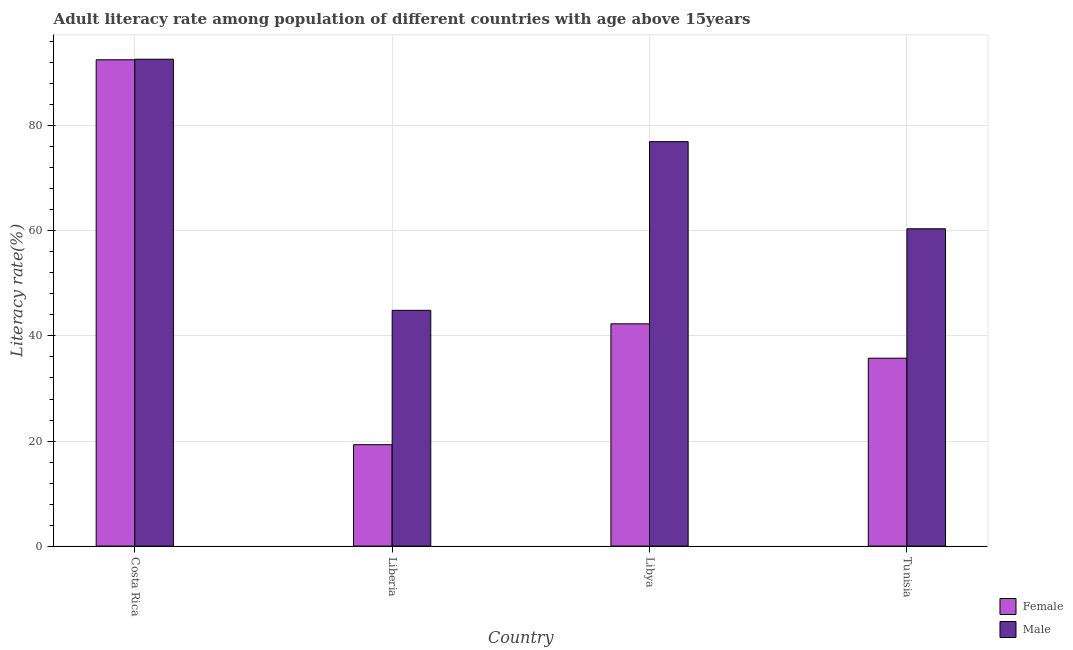Are the number of bars per tick equal to the number of legend labels?
Your answer should be compact. Yes. How many bars are there on the 2nd tick from the right?
Make the answer very short. 2. What is the male adult literacy rate in Libya?
Offer a very short reply. 76.99. Across all countries, what is the maximum male adult literacy rate?
Make the answer very short. 92.68. Across all countries, what is the minimum male adult literacy rate?
Offer a terse response. 44.88. In which country was the male adult literacy rate minimum?
Ensure brevity in your answer.  Liberia. What is the total male adult literacy rate in the graph?
Your answer should be very brief. 274.96. What is the difference between the female adult literacy rate in Liberia and that in Tunisia?
Your answer should be compact. -16.46. What is the difference between the male adult literacy rate in Liberia and the female adult literacy rate in Costa Rica?
Make the answer very short. -47.7. What is the average female adult literacy rate per country?
Provide a succinct answer. 47.49. What is the difference between the male adult literacy rate and female adult literacy rate in Tunisia?
Your answer should be very brief. 24.64. What is the ratio of the male adult literacy rate in Libya to that in Tunisia?
Provide a short and direct response. 1.27. What is the difference between the highest and the second highest female adult literacy rate?
Your answer should be very brief. 50.26. What is the difference between the highest and the lowest male adult literacy rate?
Offer a terse response. 47.8. In how many countries, is the female adult literacy rate greater than the average female adult literacy rate taken over all countries?
Provide a short and direct response. 1. Is the sum of the male adult literacy rate in Liberia and Libya greater than the maximum female adult literacy rate across all countries?
Provide a succinct answer. Yes. How many countries are there in the graph?
Make the answer very short. 4. Are the values on the major ticks of Y-axis written in scientific E-notation?
Your answer should be compact. No. Where does the legend appear in the graph?
Provide a short and direct response. Bottom right. What is the title of the graph?
Keep it short and to the point. Adult literacy rate among population of different countries with age above 15years. What is the label or title of the X-axis?
Your answer should be very brief. Country. What is the label or title of the Y-axis?
Ensure brevity in your answer.  Literacy rate(%). What is the Literacy rate(%) of Female in Costa Rica?
Your answer should be very brief. 92.58. What is the Literacy rate(%) of Male in Costa Rica?
Offer a terse response. 92.68. What is the Literacy rate(%) in Female in Liberia?
Keep it short and to the point. 19.3. What is the Literacy rate(%) of Male in Liberia?
Make the answer very short. 44.88. What is the Literacy rate(%) in Female in Libya?
Offer a terse response. 42.31. What is the Literacy rate(%) in Male in Libya?
Your answer should be compact. 76.99. What is the Literacy rate(%) of Female in Tunisia?
Your answer should be very brief. 35.77. What is the Literacy rate(%) of Male in Tunisia?
Give a very brief answer. 60.41. Across all countries, what is the maximum Literacy rate(%) of Female?
Your response must be concise. 92.58. Across all countries, what is the maximum Literacy rate(%) in Male?
Provide a short and direct response. 92.68. Across all countries, what is the minimum Literacy rate(%) in Female?
Make the answer very short. 19.3. Across all countries, what is the minimum Literacy rate(%) in Male?
Make the answer very short. 44.88. What is the total Literacy rate(%) in Female in the graph?
Provide a short and direct response. 189.96. What is the total Literacy rate(%) in Male in the graph?
Make the answer very short. 274.96. What is the difference between the Literacy rate(%) of Female in Costa Rica and that in Liberia?
Ensure brevity in your answer.  73.27. What is the difference between the Literacy rate(%) of Male in Costa Rica and that in Liberia?
Provide a succinct answer. 47.8. What is the difference between the Literacy rate(%) of Female in Costa Rica and that in Libya?
Your answer should be very brief. 50.26. What is the difference between the Literacy rate(%) in Male in Costa Rica and that in Libya?
Make the answer very short. 15.69. What is the difference between the Literacy rate(%) in Female in Costa Rica and that in Tunisia?
Your answer should be compact. 56.81. What is the difference between the Literacy rate(%) in Male in Costa Rica and that in Tunisia?
Ensure brevity in your answer.  32.27. What is the difference between the Literacy rate(%) in Female in Liberia and that in Libya?
Your answer should be compact. -23.01. What is the difference between the Literacy rate(%) in Male in Liberia and that in Libya?
Provide a succinct answer. -32.11. What is the difference between the Literacy rate(%) in Female in Liberia and that in Tunisia?
Offer a very short reply. -16.46. What is the difference between the Literacy rate(%) of Male in Liberia and that in Tunisia?
Your response must be concise. -15.53. What is the difference between the Literacy rate(%) in Female in Libya and that in Tunisia?
Your response must be concise. 6.55. What is the difference between the Literacy rate(%) in Male in Libya and that in Tunisia?
Provide a succinct answer. 16.59. What is the difference between the Literacy rate(%) of Female in Costa Rica and the Literacy rate(%) of Male in Liberia?
Your answer should be very brief. 47.7. What is the difference between the Literacy rate(%) in Female in Costa Rica and the Literacy rate(%) in Male in Libya?
Make the answer very short. 15.58. What is the difference between the Literacy rate(%) of Female in Costa Rica and the Literacy rate(%) of Male in Tunisia?
Your answer should be compact. 32.17. What is the difference between the Literacy rate(%) in Female in Liberia and the Literacy rate(%) in Male in Libya?
Provide a short and direct response. -57.69. What is the difference between the Literacy rate(%) of Female in Liberia and the Literacy rate(%) of Male in Tunisia?
Keep it short and to the point. -41.1. What is the difference between the Literacy rate(%) of Female in Libya and the Literacy rate(%) of Male in Tunisia?
Make the answer very short. -18.09. What is the average Literacy rate(%) of Female per country?
Offer a very short reply. 47.49. What is the average Literacy rate(%) of Male per country?
Offer a terse response. 68.74. What is the difference between the Literacy rate(%) of Female and Literacy rate(%) of Male in Costa Rica?
Ensure brevity in your answer.  -0.1. What is the difference between the Literacy rate(%) of Female and Literacy rate(%) of Male in Liberia?
Your response must be concise. -25.58. What is the difference between the Literacy rate(%) of Female and Literacy rate(%) of Male in Libya?
Provide a short and direct response. -34.68. What is the difference between the Literacy rate(%) of Female and Literacy rate(%) of Male in Tunisia?
Your response must be concise. -24.64. What is the ratio of the Literacy rate(%) in Female in Costa Rica to that in Liberia?
Provide a succinct answer. 4.8. What is the ratio of the Literacy rate(%) of Male in Costa Rica to that in Liberia?
Make the answer very short. 2.07. What is the ratio of the Literacy rate(%) in Female in Costa Rica to that in Libya?
Keep it short and to the point. 2.19. What is the ratio of the Literacy rate(%) of Male in Costa Rica to that in Libya?
Provide a short and direct response. 1.2. What is the ratio of the Literacy rate(%) in Female in Costa Rica to that in Tunisia?
Give a very brief answer. 2.59. What is the ratio of the Literacy rate(%) in Male in Costa Rica to that in Tunisia?
Ensure brevity in your answer.  1.53. What is the ratio of the Literacy rate(%) in Female in Liberia to that in Libya?
Your answer should be very brief. 0.46. What is the ratio of the Literacy rate(%) of Male in Liberia to that in Libya?
Your response must be concise. 0.58. What is the ratio of the Literacy rate(%) in Female in Liberia to that in Tunisia?
Offer a terse response. 0.54. What is the ratio of the Literacy rate(%) of Male in Liberia to that in Tunisia?
Your answer should be very brief. 0.74. What is the ratio of the Literacy rate(%) of Female in Libya to that in Tunisia?
Give a very brief answer. 1.18. What is the ratio of the Literacy rate(%) of Male in Libya to that in Tunisia?
Provide a short and direct response. 1.27. What is the difference between the highest and the second highest Literacy rate(%) in Female?
Your answer should be very brief. 50.26. What is the difference between the highest and the second highest Literacy rate(%) of Male?
Your response must be concise. 15.69. What is the difference between the highest and the lowest Literacy rate(%) in Female?
Your response must be concise. 73.27. What is the difference between the highest and the lowest Literacy rate(%) in Male?
Offer a very short reply. 47.8. 